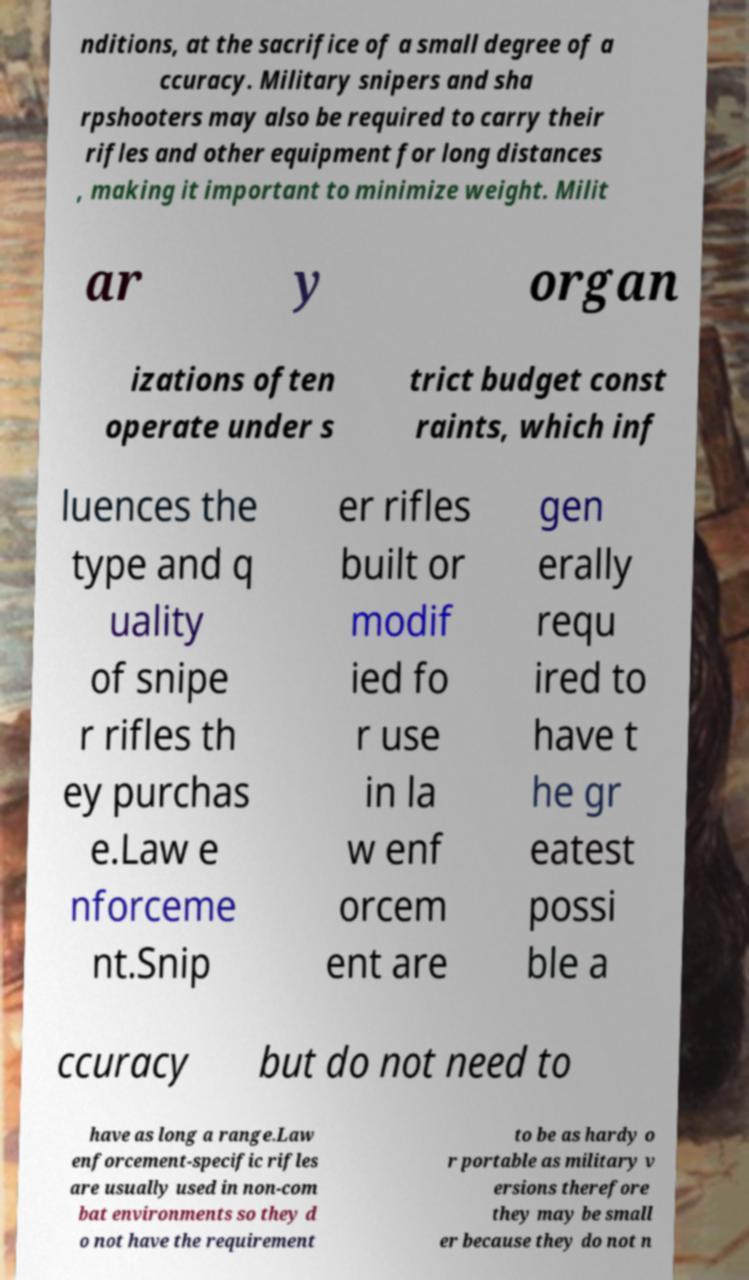Please read and relay the text visible in this image. What does it say? nditions, at the sacrifice of a small degree of a ccuracy. Military snipers and sha rpshooters may also be required to carry their rifles and other equipment for long distances , making it important to minimize weight. Milit ar y organ izations often operate under s trict budget const raints, which inf luences the type and q uality of snipe r rifles th ey purchas e.Law e nforceme nt.Snip er rifles built or modif ied fo r use in la w enf orcem ent are gen erally requ ired to have t he gr eatest possi ble a ccuracy but do not need to have as long a range.Law enforcement-specific rifles are usually used in non-com bat environments so they d o not have the requirement to be as hardy o r portable as military v ersions therefore they may be small er because they do not n 